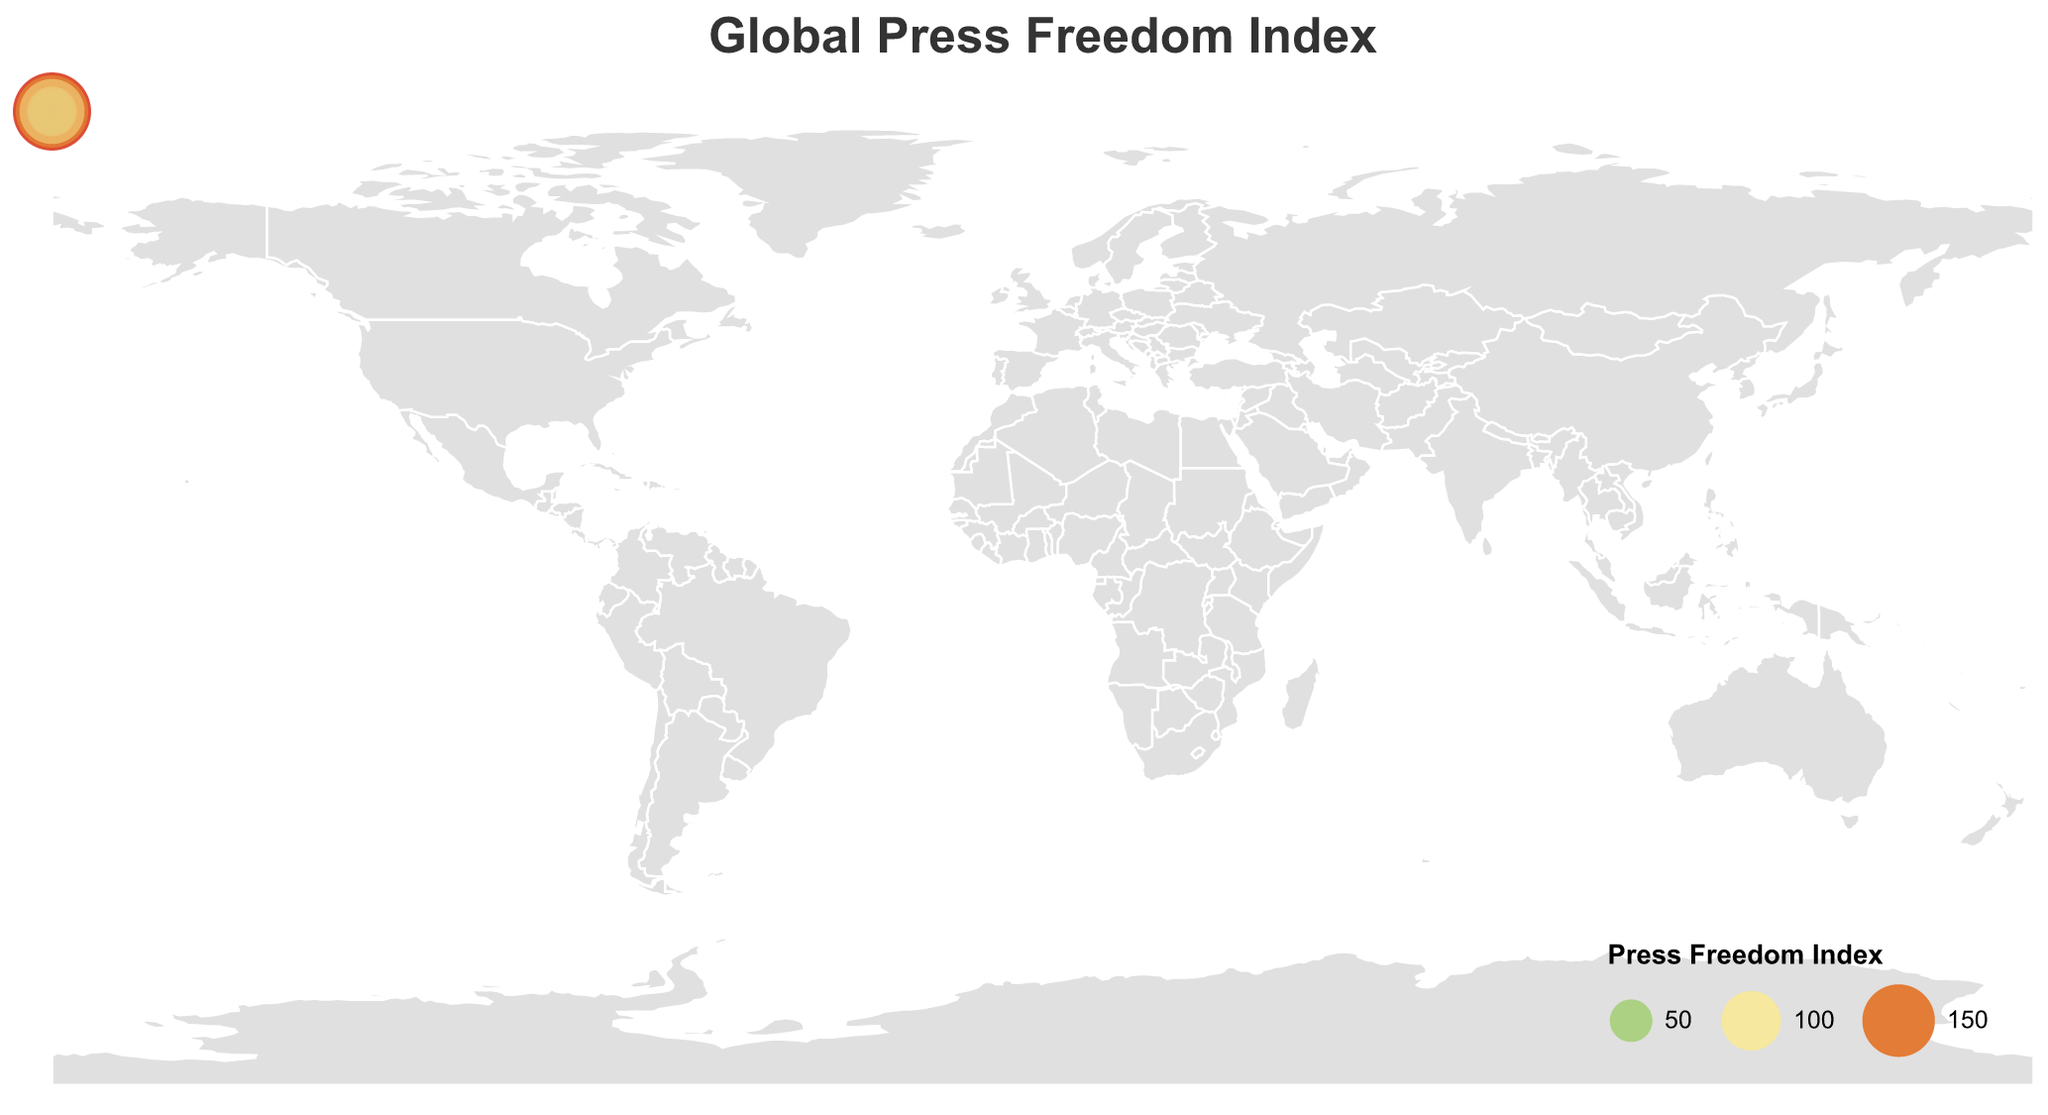What is the title of the figure? The figure's title is placed at the top center and is in a 20-point Arial font, indicating the topic of the visualization.
Answer: Global Press Freedom Index Which country has the best press freedom index? The country with the best press freedom index will have the smallest numerical value. The figure indicates that Norway has the lowest index value of 1.
Answer: Norway Which country has the worst press freedom index? The country with the worst press freedom index will have the largest numerical value. The plot shows that China has the highest index value of 175.
Answer: China How does the press freedom in the United States compare to Canada? To compare the two countries, we look at their index values. The United States has an index of 42, whereas Canada has an index of 19. Thus, the press freedom is better in Canada.
Answer: Canada has better press freedom Among the United Kingdom, Germany, and France, which country has the highest press freedom index? To determine the highest press freedom index among these countries, compare their values: United Kingdom (24), Germany (16), France (26). France has the highest among the three.
Answer: France What is the average press freedom index of the countries listed? Sum the press freedom indices of all the countries, then divide by the number of countries (20). Sum = 42 + 1 + 175 + 155 + 24 + 16 + 26 + 71 + 110 + 150 + 35 + 25 + 19 + 128 + 168 + 149 + 3 + 57 + 69 + 120 = 1573. Average = 1573 / 20 = 78.65
Answer: 78.65 Which continent appears to have better press freedom based on the countries listed in the data? Determine the indices of countries by continent and calculate the average for each. Europe: Norway (1), United Kingdom (24), Germany (16), France (26), Sweden (3), Poland (57). Sum Euro: 127, Avg Euro: 21.17. North America: United States (42), Canada (19), Mexico (128). Sum NA: 189, Avg NA: 63. Middle East: Egypt (168), Turkey (149). Sum ME: 317, Avg ME: 158.5. Africa: South Africa (35), Nigeria (120). Sum Afr: 155, Avg Afr: 77.5. Asia: China (175), Japan (71), India (150). Sum Asia: 396, Avg Asia: 132. Australia as continent: Australia (25). South America: Brazil (110), Argentina (69). Avg SA: 89.5. So, Europe has better press freedom.
Answer: Europe What color represents countries with the worst press freedom? Identify the color on the plot's scale corresponding to the highest index values, ranging to a deep red (#d73027). Countries like China and Egypt are marked in deep red, indicating the worst press freedom.
Answer: Deep red How does the press freedom index of Brazil compare to that of South Africa? Brazil and South Africa have indices of 110 and 35, respectively. The lower value indicates better press freedom; hence, South Africa has better press freedom.
Answer: South Africa has better press freedom Which country is close to the median press freedom index of the countries listed? Arrange the indices in ascending order and find the middle value: 1, 3, 16, 19, 24, 25, 26, 35, 42, 57, 69, 71, 110, 120, 128, 149, 150, 155, 168, 175. Median is (35 + 42) / 2 = 38.5. The closest countries around 38.5 are South Africa (35) and the United States (42).
Answer: South Africa and the United States 